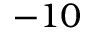Convert formula to latex. <formula><loc_0><loc_0><loc_500><loc_500>- 1 0</formula> 